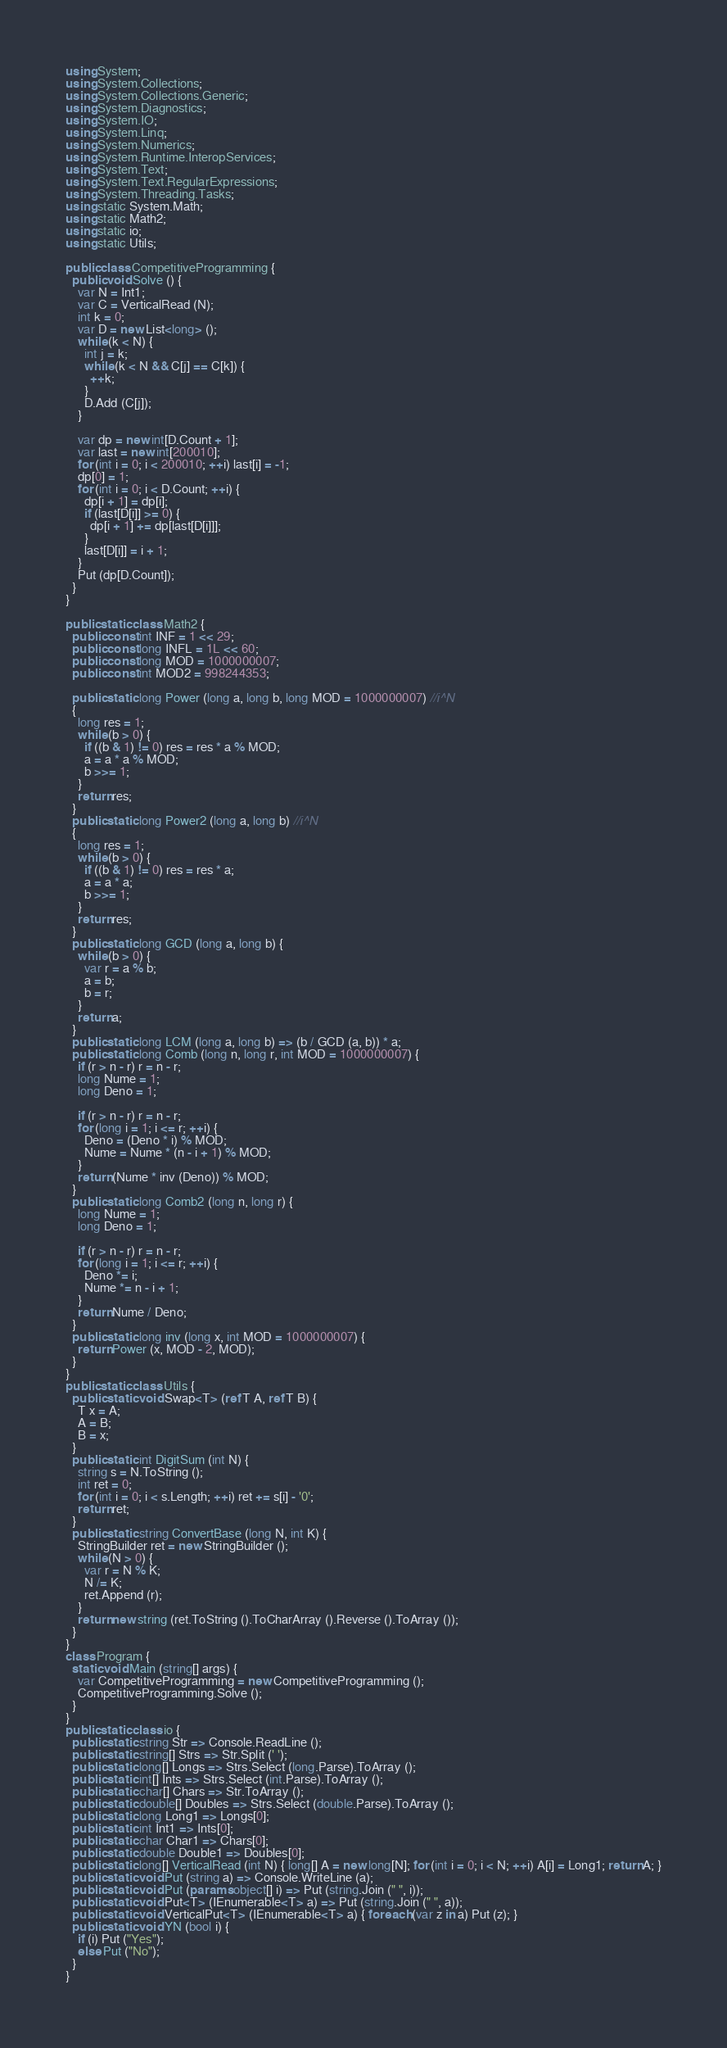<code> <loc_0><loc_0><loc_500><loc_500><_C#_>using System;
using System.Collections;
using System.Collections.Generic;
using System.Diagnostics;
using System.IO;
using System.Linq;
using System.Numerics;
using System.Runtime.InteropServices;
using System.Text;
using System.Text.RegularExpressions;
using System.Threading.Tasks;
using static System.Math;
using static Math2;
using static io;
using static Utils;

public class CompetitiveProgramming {
  public void Solve () {
    var N = Int1;
    var C = VerticalRead (N);
    int k = 0;
    var D = new List<long> ();
    while (k < N) {
      int j = k;
      while (k < N && C[j] == C[k]) {
        ++k;
      }
      D.Add (C[j]);
    }

    var dp = new int[D.Count + 1];
    var last = new int[200010];
    for (int i = 0; i < 200010; ++i) last[i] = -1;
    dp[0] = 1;
    for (int i = 0; i < D.Count; ++i) {
      dp[i + 1] = dp[i];
      if (last[D[i]] >= 0) {
        dp[i + 1] += dp[last[D[i]]];
      }
      last[D[i]] = i + 1;
    }
    Put (dp[D.Count]);
  }
}

public static class Math2 {
  public const int INF = 1 << 29;
  public const long INFL = 1L << 60;
  public const long MOD = 1000000007;
  public const int MOD2 = 998244353;

  public static long Power (long a, long b, long MOD = 1000000007) //i^N
  {
    long res = 1;
    while (b > 0) {
      if ((b & 1) != 0) res = res * a % MOD;
      a = a * a % MOD;
      b >>= 1;
    }
    return res;
  }
  public static long Power2 (long a, long b) //i^N
  {
    long res = 1;
    while (b > 0) {
      if ((b & 1) != 0) res = res * a;
      a = a * a;
      b >>= 1;
    }
    return res;
  }
  public static long GCD (long a, long b) {
    while (b > 0) {
      var r = a % b;
      a = b;
      b = r;
    }
    return a;
  }
  public static long LCM (long a, long b) => (b / GCD (a, b)) * a;
  public static long Comb (long n, long r, int MOD = 1000000007) {
    if (r > n - r) r = n - r;
    long Nume = 1;
    long Deno = 1;

    if (r > n - r) r = n - r;
    for (long i = 1; i <= r; ++i) {
      Deno = (Deno * i) % MOD;
      Nume = Nume * (n - i + 1) % MOD;
    }
    return (Nume * inv (Deno)) % MOD;
  }
  public static long Comb2 (long n, long r) {
    long Nume = 1;
    long Deno = 1;

    if (r > n - r) r = n - r;
    for (long i = 1; i <= r; ++i) {
      Deno *= i;
      Nume *= n - i + 1;
    }
    return Nume / Deno;
  }
  public static long inv (long x, int MOD = 1000000007) {
    return Power (x, MOD - 2, MOD);
  }
}
public static class Utils {
  public static void Swap<T> (ref T A, ref T B) {
    T x = A;
    A = B;
    B = x;
  }
  public static int DigitSum (int N) {
    string s = N.ToString ();
    int ret = 0;
    for (int i = 0; i < s.Length; ++i) ret += s[i] - '0';
    return ret;
  }
  public static string ConvertBase (long N, int K) {
    StringBuilder ret = new StringBuilder ();
    while (N > 0) {
      var r = N % K;
      N /= K;
      ret.Append (r);
    }
    return new string (ret.ToString ().ToCharArray ().Reverse ().ToArray ());
  }
}
class Program {
  static void Main (string[] args) {
    var CompetitiveProgramming = new CompetitiveProgramming ();
    CompetitiveProgramming.Solve ();
  }
}
public static class io {
  public static string Str => Console.ReadLine ();
  public static string[] Strs => Str.Split (' ');
  public static long[] Longs => Strs.Select (long.Parse).ToArray ();
  public static int[] Ints => Strs.Select (int.Parse).ToArray ();
  public static char[] Chars => Str.ToArray ();
  public static double[] Doubles => Strs.Select (double.Parse).ToArray ();
  public static long Long1 => Longs[0];
  public static int Int1 => Ints[0];
  public static char Char1 => Chars[0];
  public static double Double1 => Doubles[0];
  public static long[] VerticalRead (int N) { long[] A = new long[N]; for (int i = 0; i < N; ++i) A[i] = Long1; return A; }
  public static void Put (string a) => Console.WriteLine (a);
  public static void Put (params object[] i) => Put (string.Join (" ", i));
  public static void Put<T> (IEnumerable<T> a) => Put (string.Join (" ", a));
  public static void VerticalPut<T> (IEnumerable<T> a) { foreach (var z in a) Put (z); }
  public static void YN (bool i) {
    if (i) Put ("Yes");
    else Put ("No");
  }
}</code> 